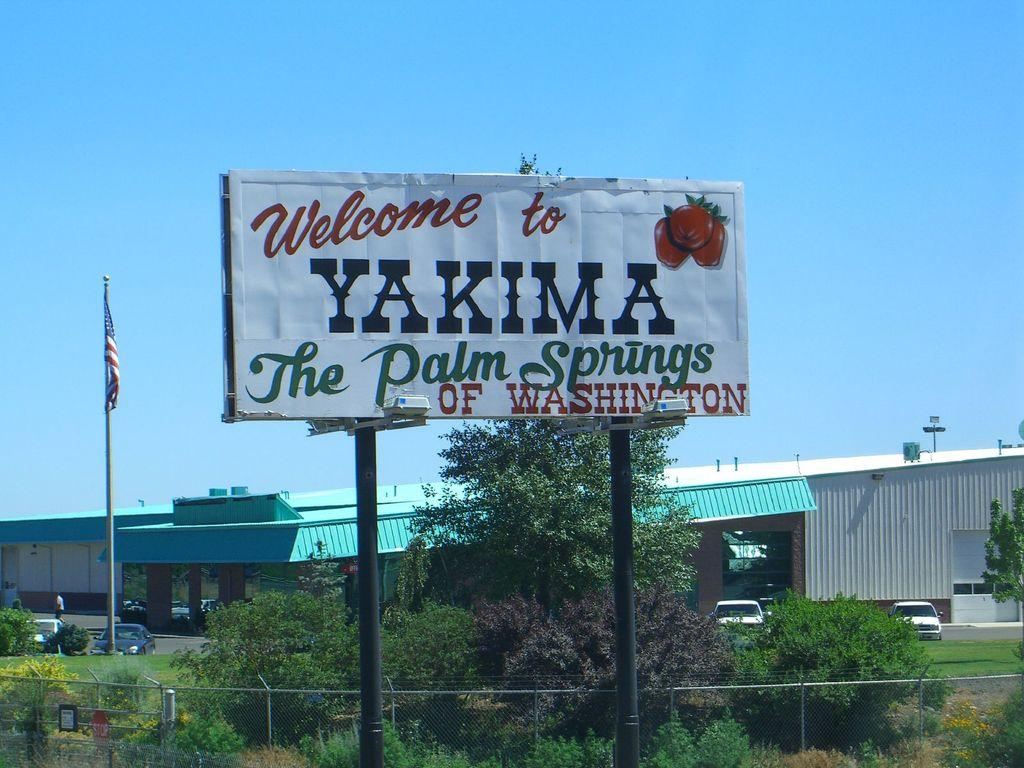<image>
Summarize the visual content of the image. A sign that reads Welcome to YAKIMA The Palm Springs OF WASHINGTON. 